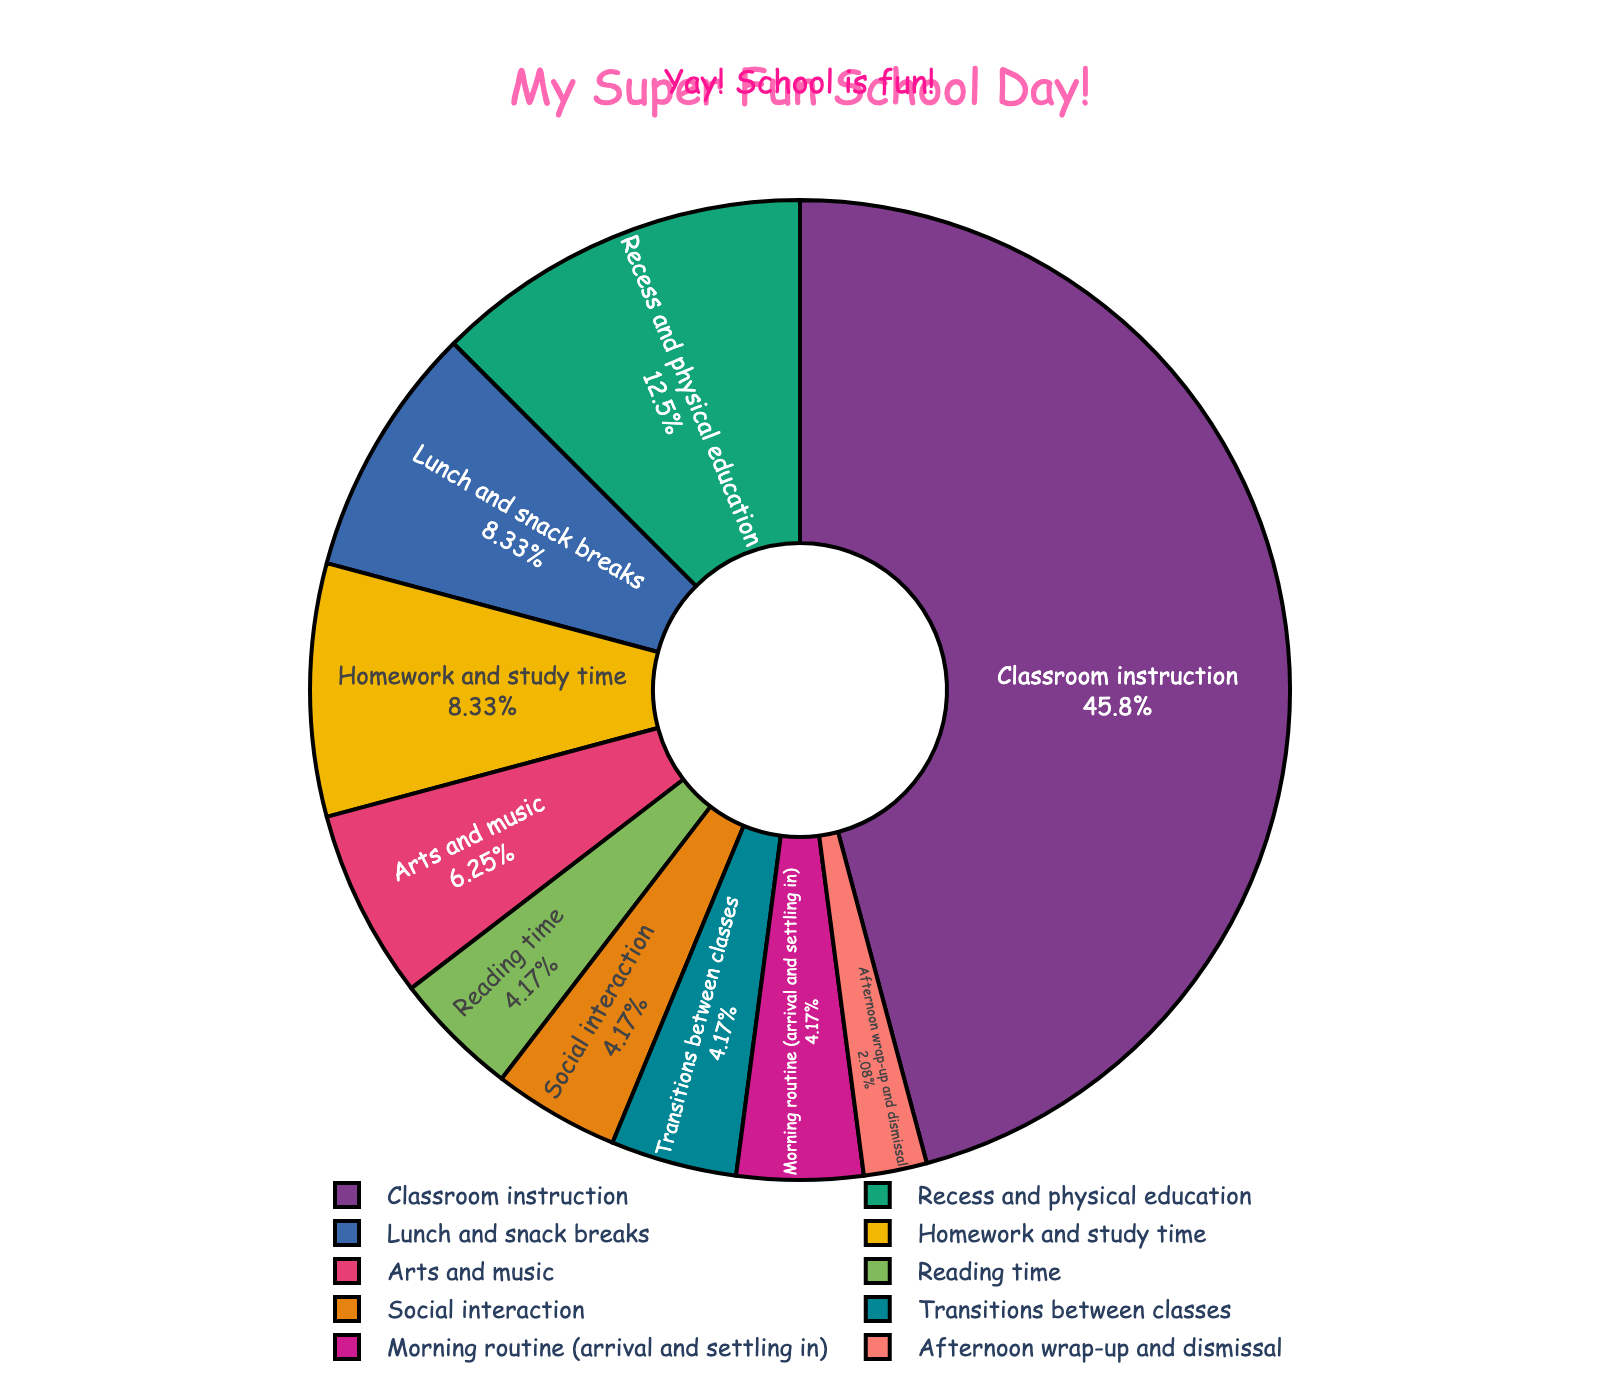What's the total duration of lunch and snack breaks along with reading time? First, find the duration of each activity: lunch and snack breaks account for 1 hour, and reading time accounts for 0.5 hours. Now, add these durations: 1 + 0.5 = 1.5 hours.
Answer: 1.5 hours Which activity takes up the largest portion of the school day? The size of each activity segment on the pie chart can be identified by their corresponding percentages or segment sizes. Classroom instruction has the largest segment, which indicates it occupies the largest portion of the school day.
Answer: Classroom instruction How much more time is spent on recess and physical education compared to transitions between classes? Time spent on recess and physical education is 1.5 hours, while transitions between classes take 0.5 hours. Subtract the time for transitions between classes from the time for recess and physical education: 1.5 - 0.5 = 1 hour.
Answer: 1 hour What's the total time spent on classroom instruction, homework, and study time? Identify the hours for each activity: Classroom instruction is 5.5 hours, and homework and study time is 1 hour. Add these durations: 5.5 + 1 = 6.5 hours.
Answer: 6.5 hours Which activities have equal time durations? The activities represented by equal-sized segments are those with the same number of hours. Reading time, social interaction, and transitions between classes each account for 0.5 hours.
Answer: Reading time, social interaction, transitions between classes What percentage of the school day is dedicated to arts and music? Find the specific segment labeled arts and music on the pie chart. The chart shows that arts and music take up 0.75 hours out of a total of 12 hours. To find the percentage, divide 0.75 by 12 and multiply by 100: (0.75 / 12) * 100 ≈ 6.25%.
Answer: 6.25% Which activity has the smallest slice in the pie chart? By examining the pie chart, the smallest slice corresponds to the activity with the least hours. The afternoon wrap-up and dismissal is 0.25 hours, the smallest in the chart.
Answer: Afternoon wrap-up and dismissal If we combine the time spent on morning routine and afternoon wrap-up and dismissal, how much time is spent in these routines? The morning routine duration is 0.5 hours, and the afternoon wrap-up and dismissal duration is 0.25 hours. Sum these durations: 0.5 + 0.25 = 0.75 hours.
Answer: 0.75 hours 